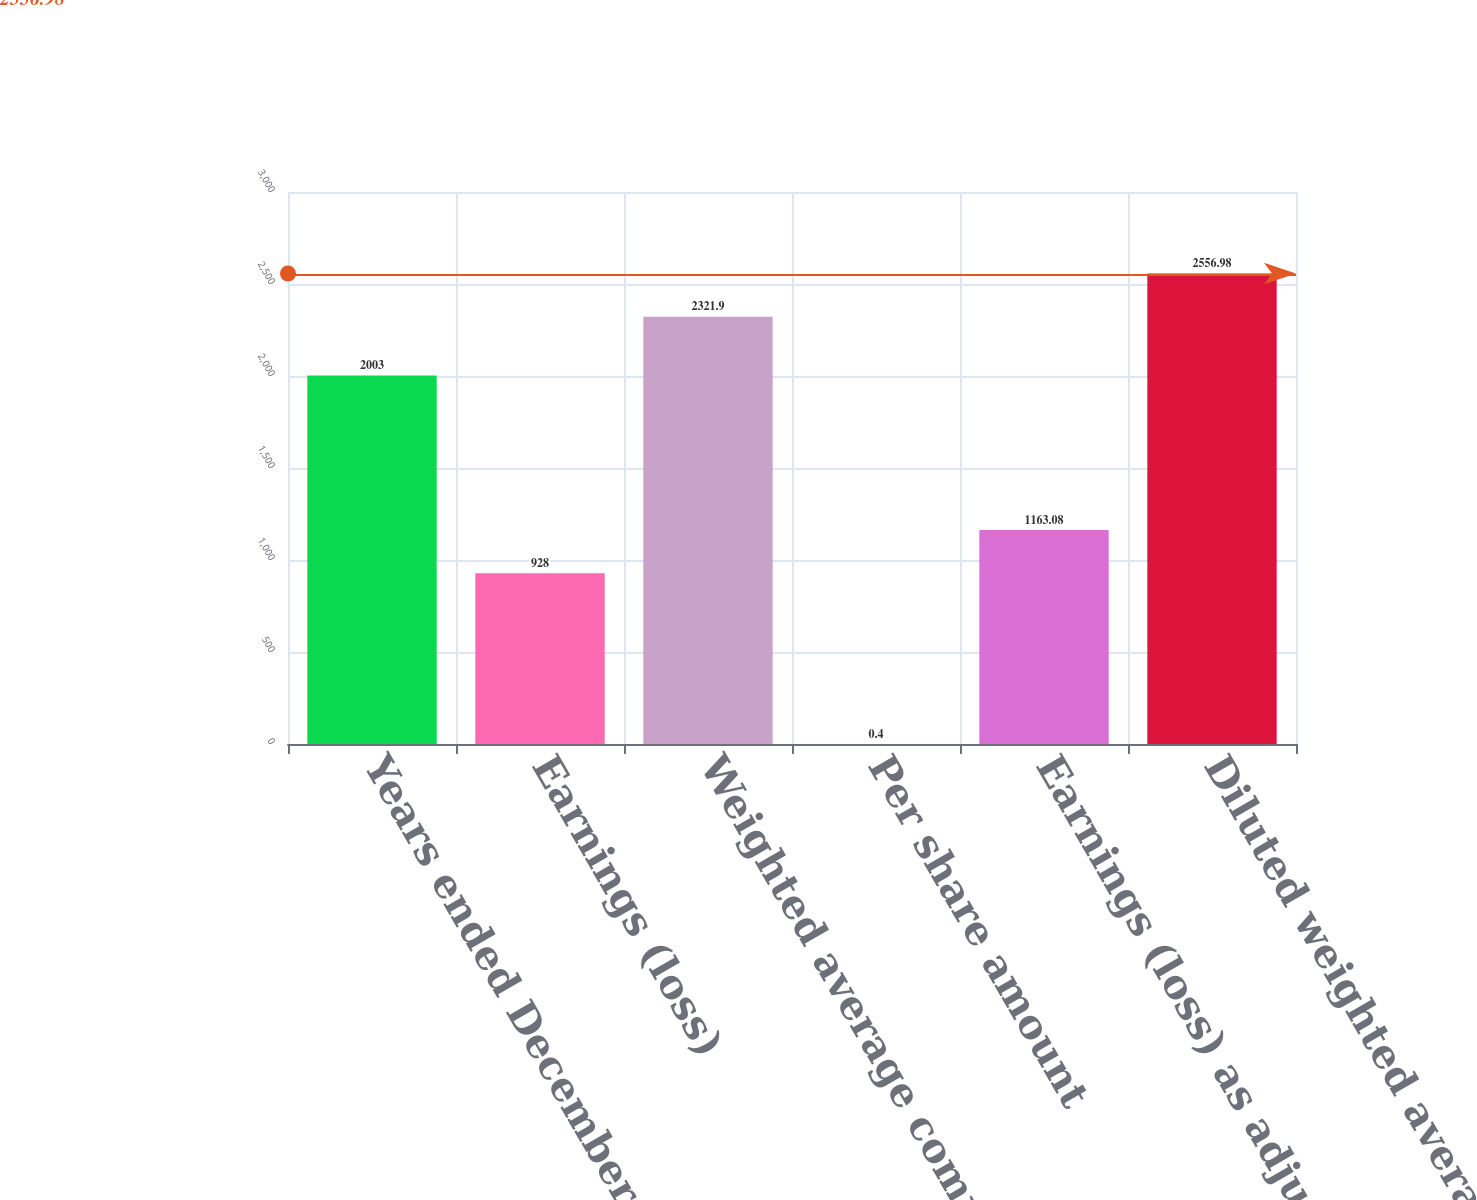Convert chart to OTSL. <chart><loc_0><loc_0><loc_500><loc_500><bar_chart><fcel>Years ended December 31<fcel>Earnings (loss)<fcel>Weighted average common shares<fcel>Per share amount<fcel>Earnings (loss) as adjusted<fcel>Diluted weighted average<nl><fcel>2003<fcel>928<fcel>2321.9<fcel>0.4<fcel>1163.08<fcel>2556.98<nl></chart> 